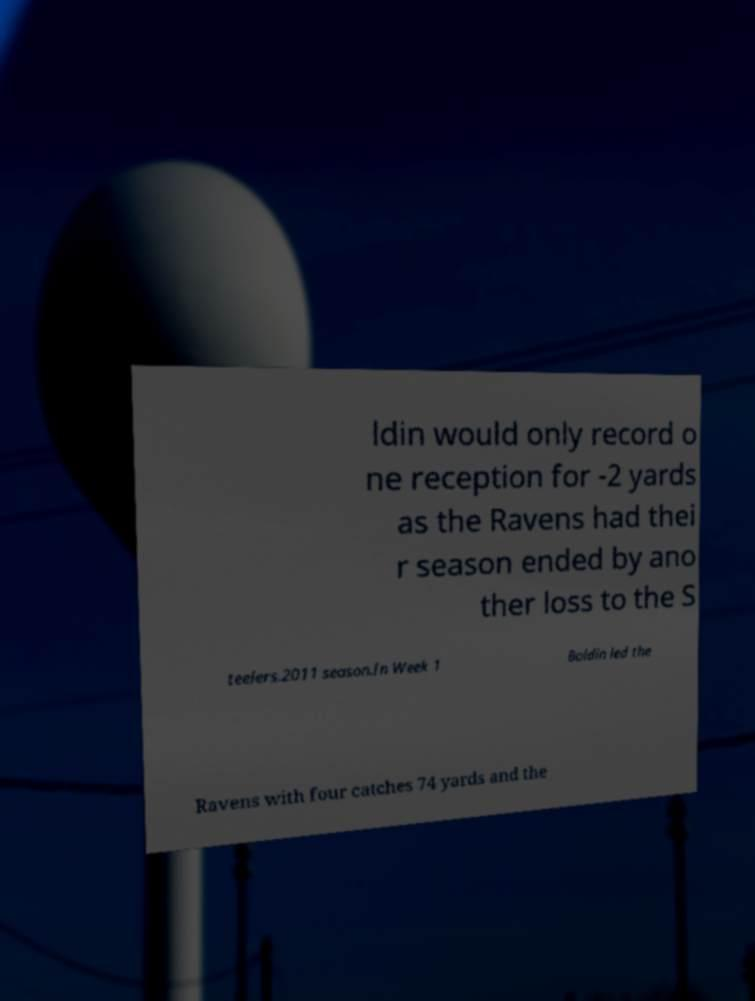Could you extract and type out the text from this image? ldin would only record o ne reception for -2 yards as the Ravens had thei r season ended by ano ther loss to the S teelers.2011 season.In Week 1 Boldin led the Ravens with four catches 74 yards and the 